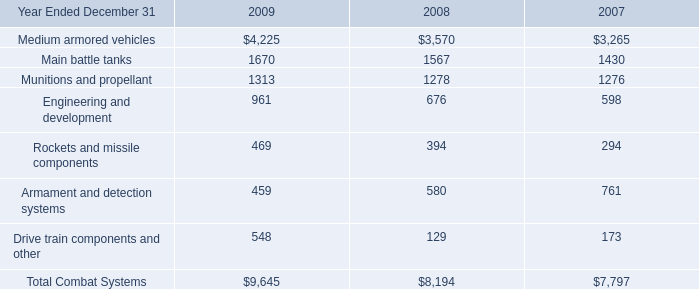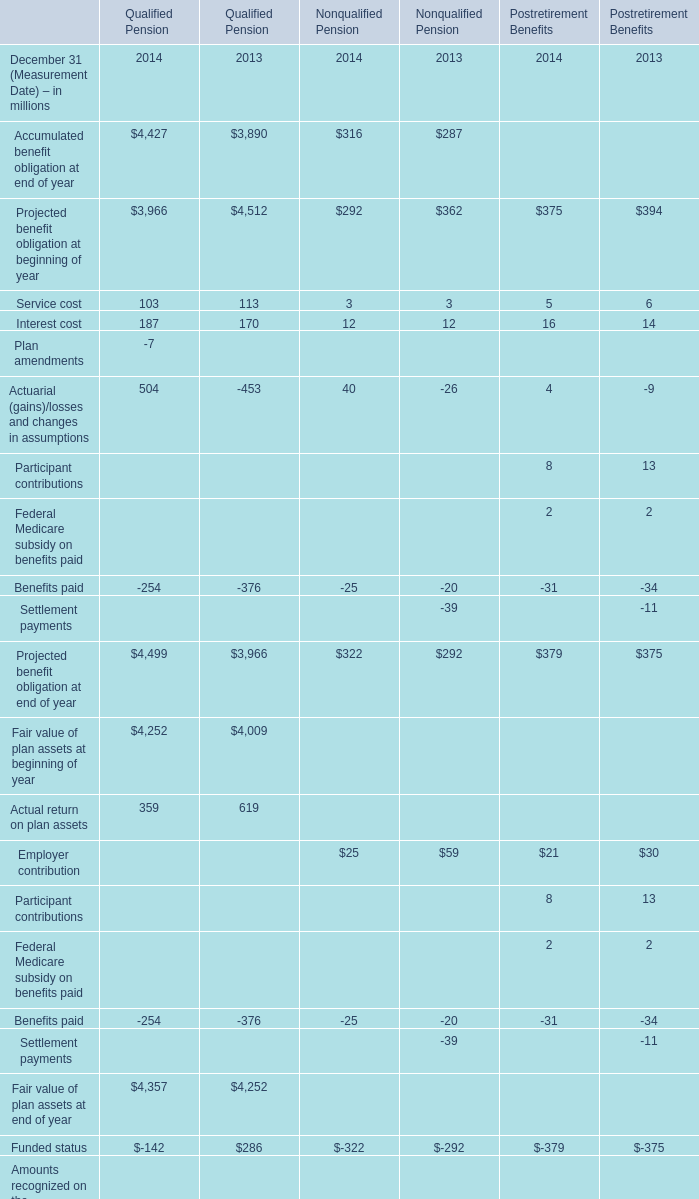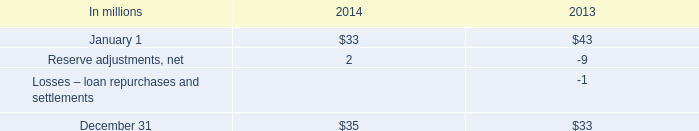What's the total value of all Qualified Pension that are in the range of -500 and 0 in 2014? (in million) 
Computations: ((((-7 - 254) - 254) - 142) - 22)
Answer: -679.0. 